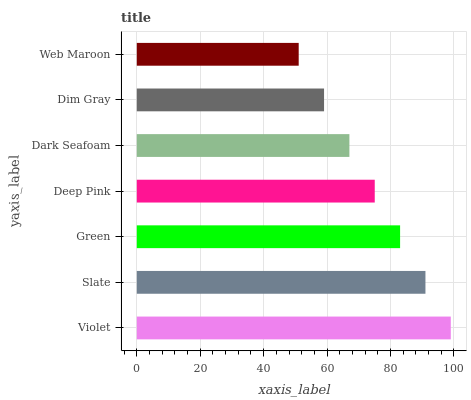Is Web Maroon the minimum?
Answer yes or no. Yes. Is Violet the maximum?
Answer yes or no. Yes. Is Slate the minimum?
Answer yes or no. No. Is Slate the maximum?
Answer yes or no. No. Is Violet greater than Slate?
Answer yes or no. Yes. Is Slate less than Violet?
Answer yes or no. Yes. Is Slate greater than Violet?
Answer yes or no. No. Is Violet less than Slate?
Answer yes or no. No. Is Deep Pink the high median?
Answer yes or no. Yes. Is Deep Pink the low median?
Answer yes or no. Yes. Is Green the high median?
Answer yes or no. No. Is Web Maroon the low median?
Answer yes or no. No. 